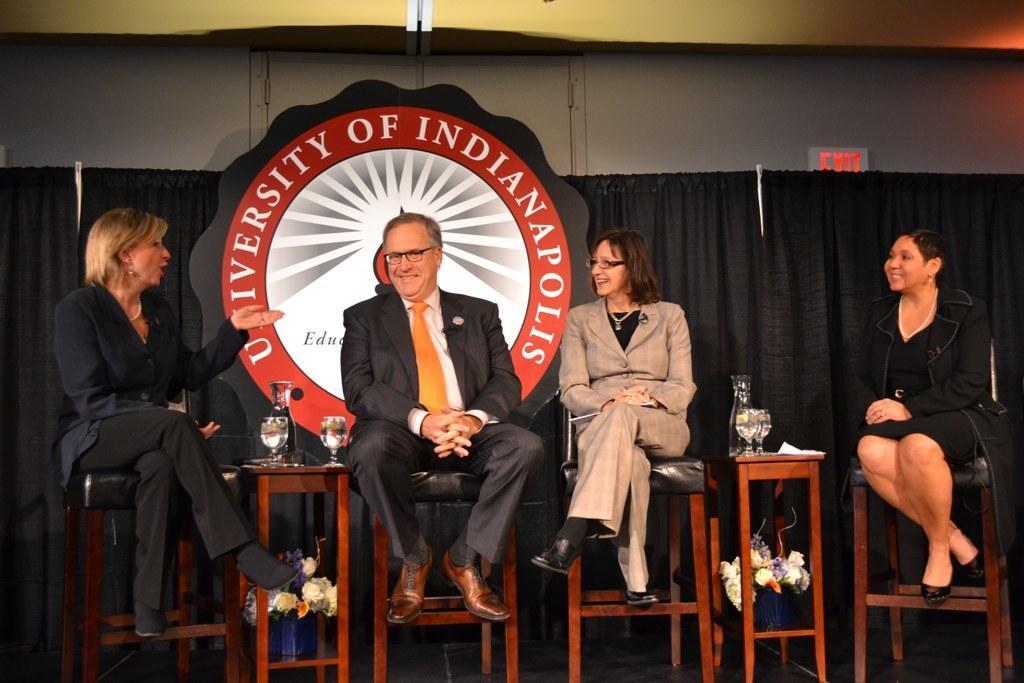Could you give a brief overview of what you see in this image? In this picture I can see four persons sitting on the stools, there are wine glasses and glass jars on the stools, there are flower vases, there is a board, and in the background there are curtains. 